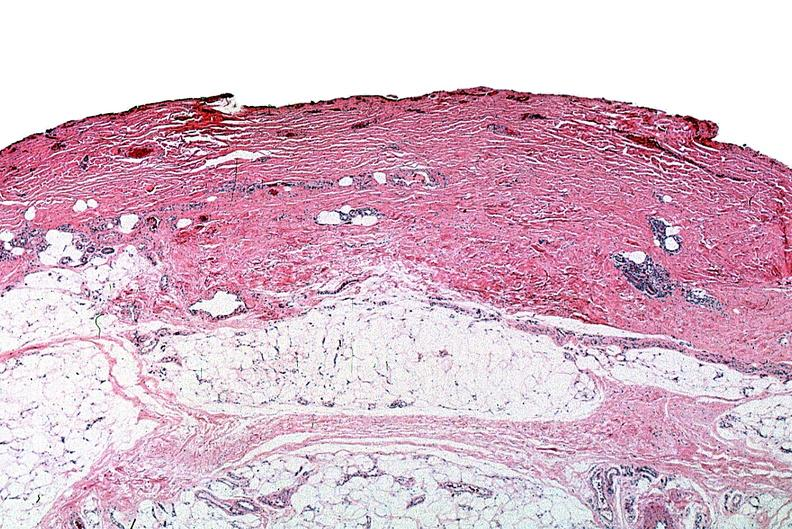what does this image show?
Answer the question using a single word or phrase. Thermal burned skin 